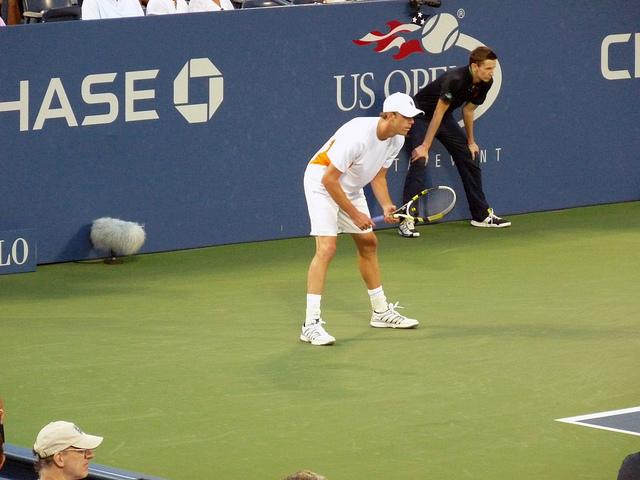Is the ball in motion?
Write a very short answer. No. Is the man going to hit the ball?
Write a very short answer. Yes. Who sponsors the tournament?
Be succinct. Chase. Is his back going to hurt later?
Concise answer only. No. What bank is advertised?
Short answer required. Chase. What color is the men's shirts?
Concise answer only. White. What sport is being played?
Short answer required. Tennis. What is the man standing near that is green?
Quick response, please. Ground. What is the man wearing on his head?
Answer briefly. Hat. What color is the man's shirt?
Concise answer only. White. Which tennis event is this?
Answer briefly. Us open. What color is the player's hat?
Give a very brief answer. White. 